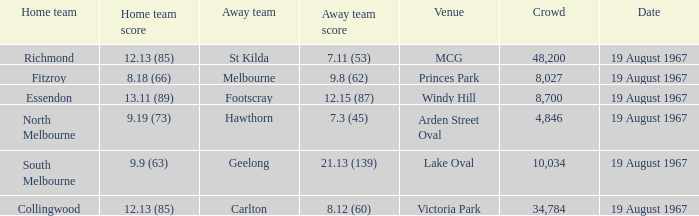Give me the full table as a dictionary. {'header': ['Home team', 'Home team score', 'Away team', 'Away team score', 'Venue', 'Crowd', 'Date'], 'rows': [['Richmond', '12.13 (85)', 'St Kilda', '7.11 (53)', 'MCG', '48,200', '19 August 1967'], ['Fitzroy', '8.18 (66)', 'Melbourne', '9.8 (62)', 'Princes Park', '8,027', '19 August 1967'], ['Essendon', '13.11 (89)', 'Footscray', '12.15 (87)', 'Windy Hill', '8,700', '19 August 1967'], ['North Melbourne', '9.19 (73)', 'Hawthorn', '7.3 (45)', 'Arden Street Oval', '4,846', '19 August 1967'], ['South Melbourne', '9.9 (63)', 'Geelong', '21.13 (139)', 'Lake Oval', '10,034', '19 August 1967'], ['Collingwood', '12.13 (85)', 'Carlton', '8.12 (60)', 'Victoria Park', '34,784', '19 August 1967']]} At lake oval venue, what score did the home team achieve? 9.9 (63). 